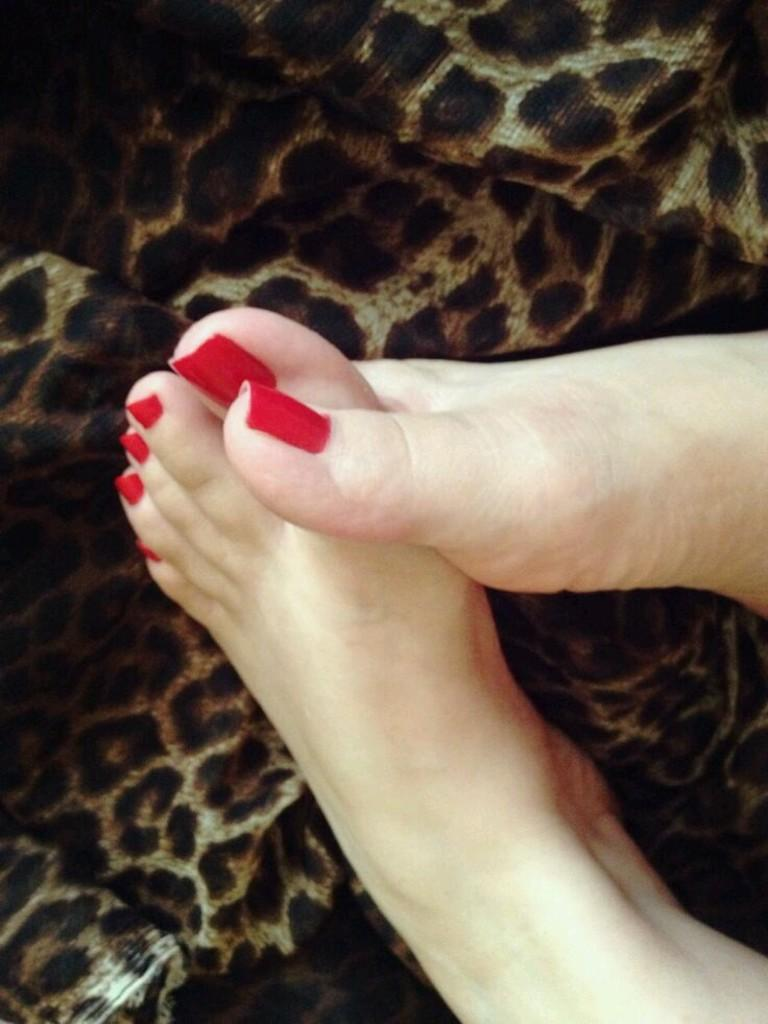What body parts are visible in the image? There are human legs visible in the image. What type of furniture can be seen in the image? There is a sofa in the image. What type of coil is being used to hold the jam in the image? There is no coil or jam present in the image. 